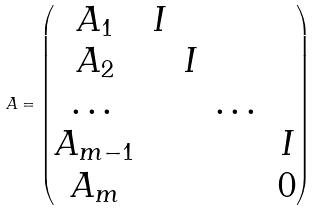Convert formula to latex. <formula><loc_0><loc_0><loc_500><loc_500>A = \begin{pmatrix} A _ { 1 } & I & & & \\ A _ { 2 } & & I & & \\ \dots & & & \dots & \\ A _ { m - 1 } & & & & I \\ A _ { m } & & & & 0 \end{pmatrix}</formula> 